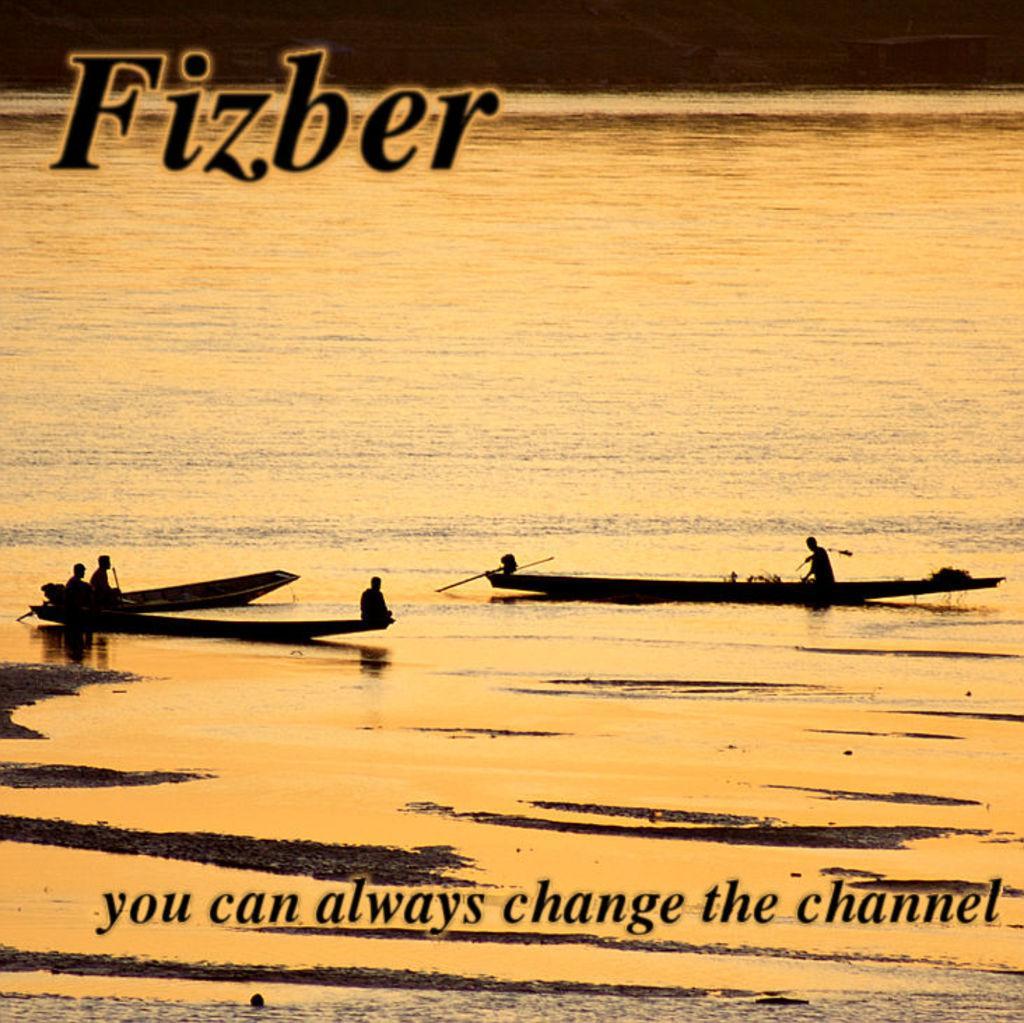In one or two sentences, can you explain what this image depicts? There is water. On the water there are boats with people. At the top and bottom something is written on the image. 